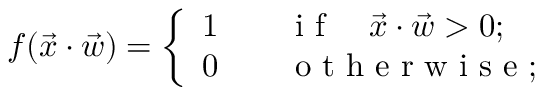Convert formula to latex. <formula><loc_0><loc_0><loc_500><loc_500>f ( \ V e c { x } \cdot \ V e c { w } ) = \left \{ \begin{array} { l l } { 1 \quad i f \quad \ V e c { x } \cdot \ V e c { w } > 0 ; } \\ { 0 \quad o t h e r w i s e ; } \end{array}</formula> 